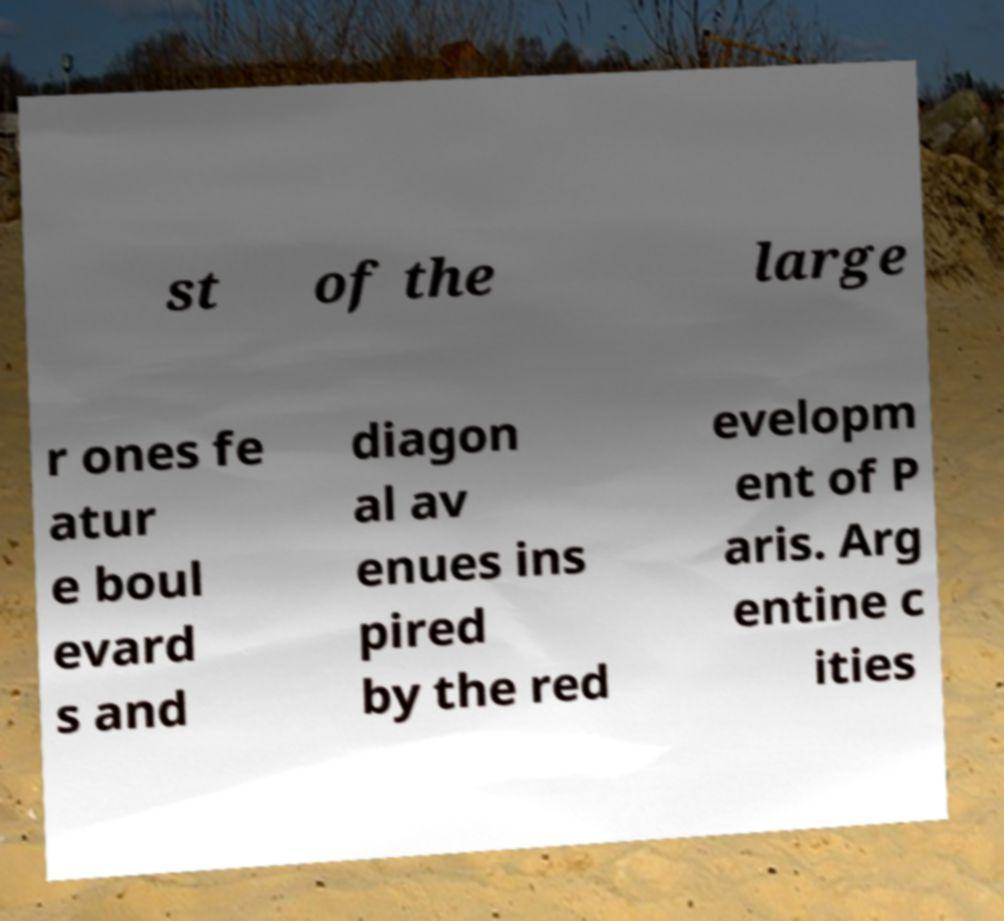Can you read and provide the text displayed in the image?This photo seems to have some interesting text. Can you extract and type it out for me? st of the large r ones fe atur e boul evard s and diagon al av enues ins pired by the red evelopm ent of P aris. Arg entine c ities 